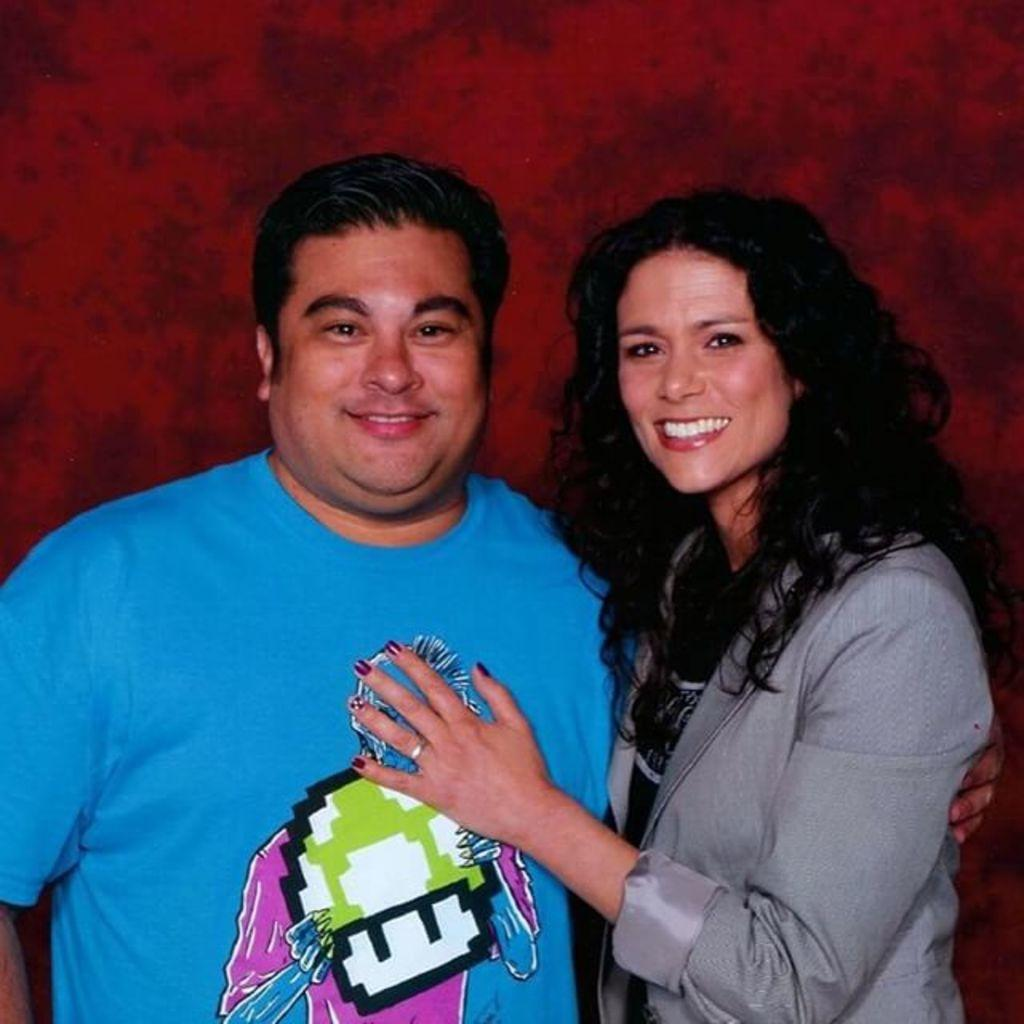How many people are in the image? There are two people in the image, a man and a woman. What are the man and woman doing in the image? The man and woman are holding each other. What type of theory does the bee in the image propose? There is no bee present in the image, so it cannot propose any theories. 